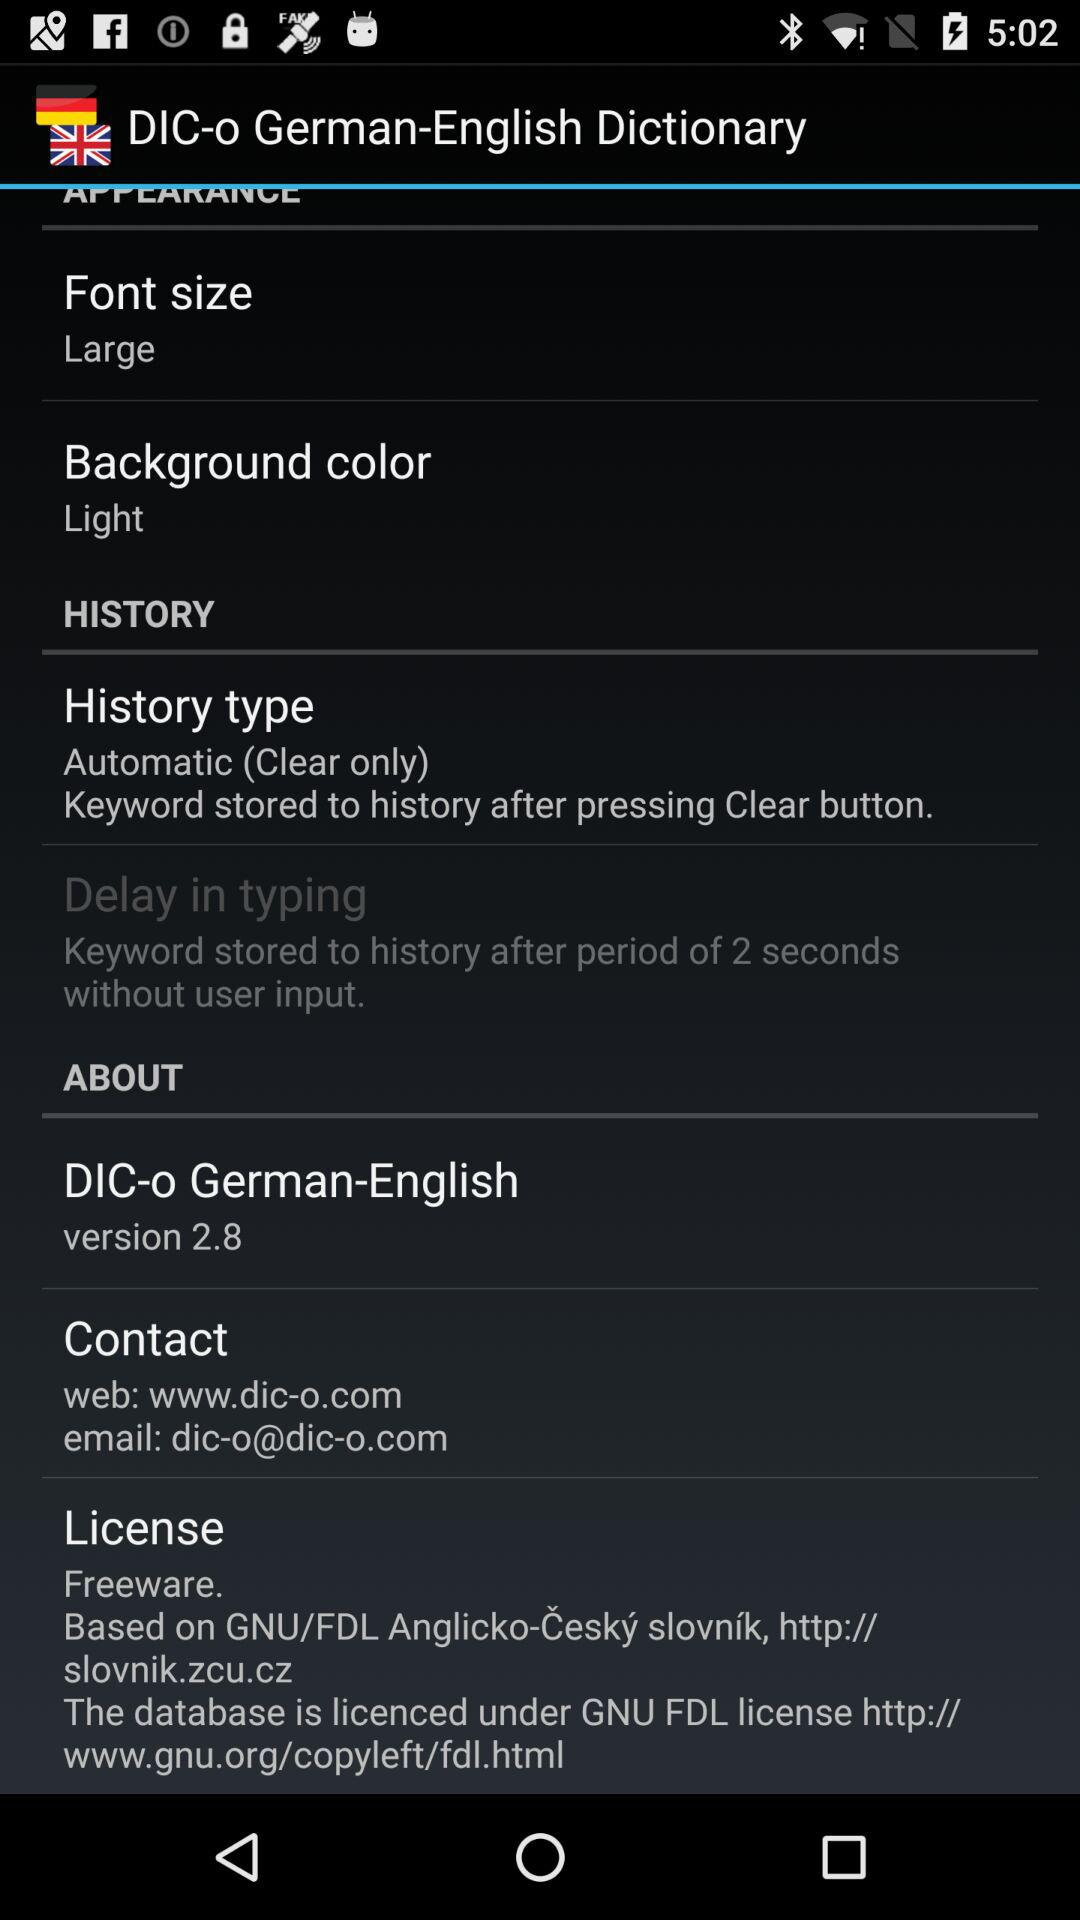What is "Font size"? "Font size" is "Large". 